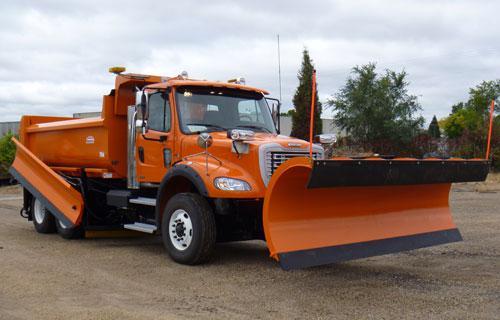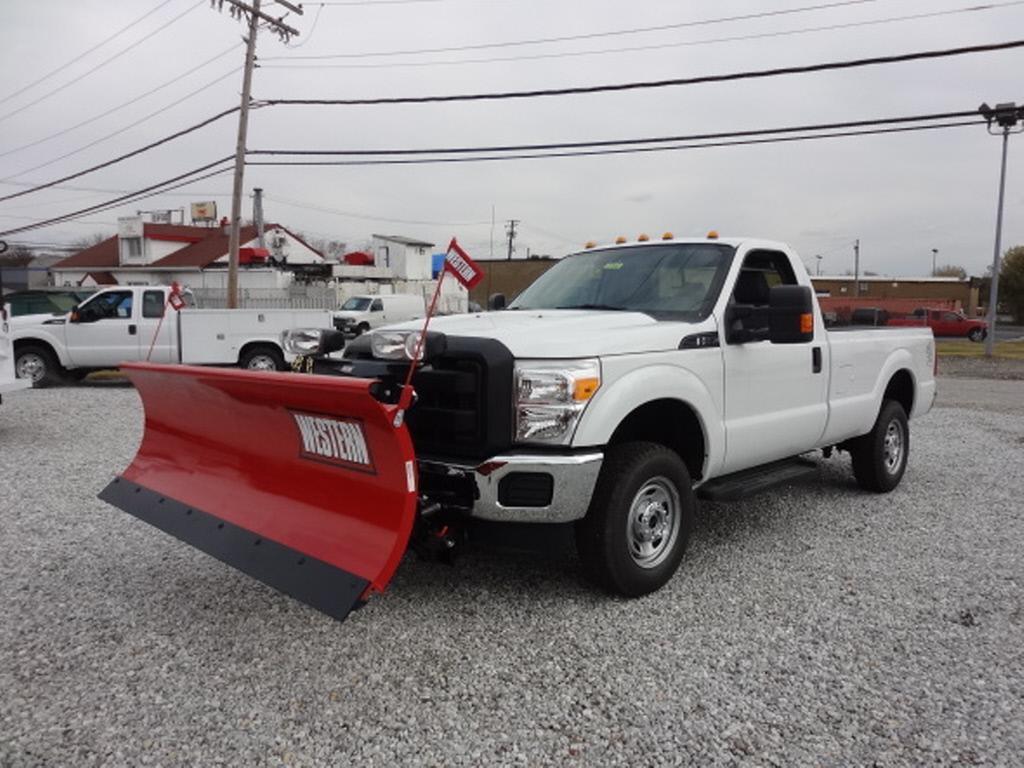The first image is the image on the left, the second image is the image on the right. Examine the images to the left and right. Is the description "At least one image shows a vehicle with tank-like tracks instead of wheels." accurate? Answer yes or no. No. 